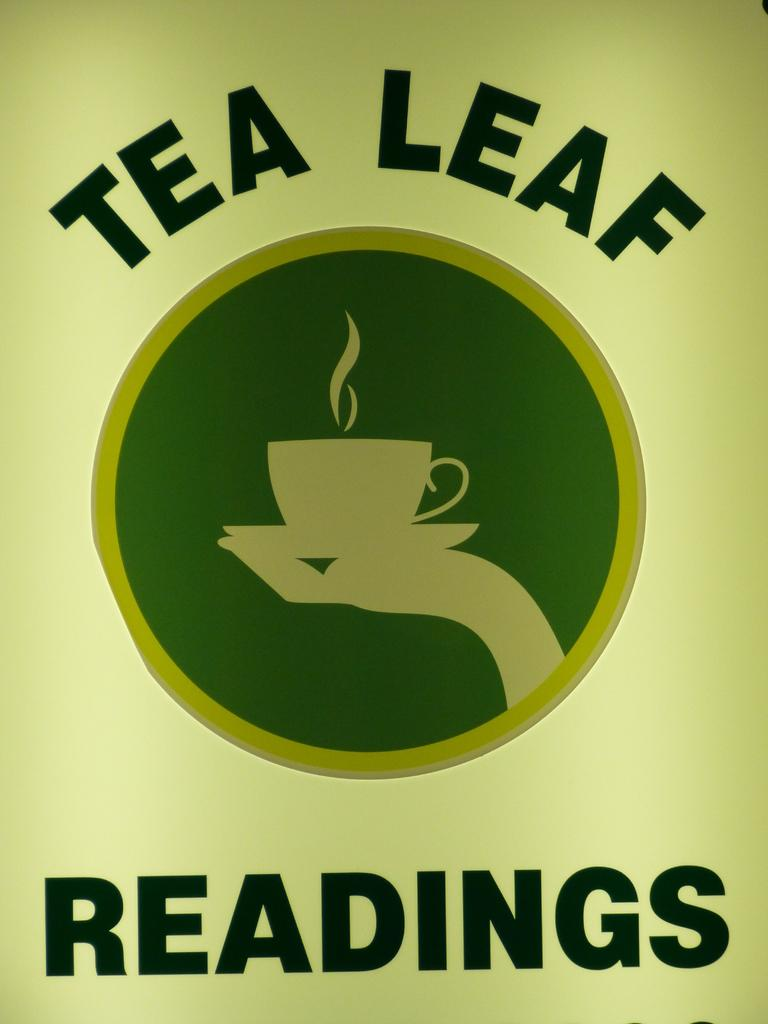<image>
Share a concise interpretation of the image provided. Tea Leaf Readings is written around a logo of a hand holding a cup on a saucer. 